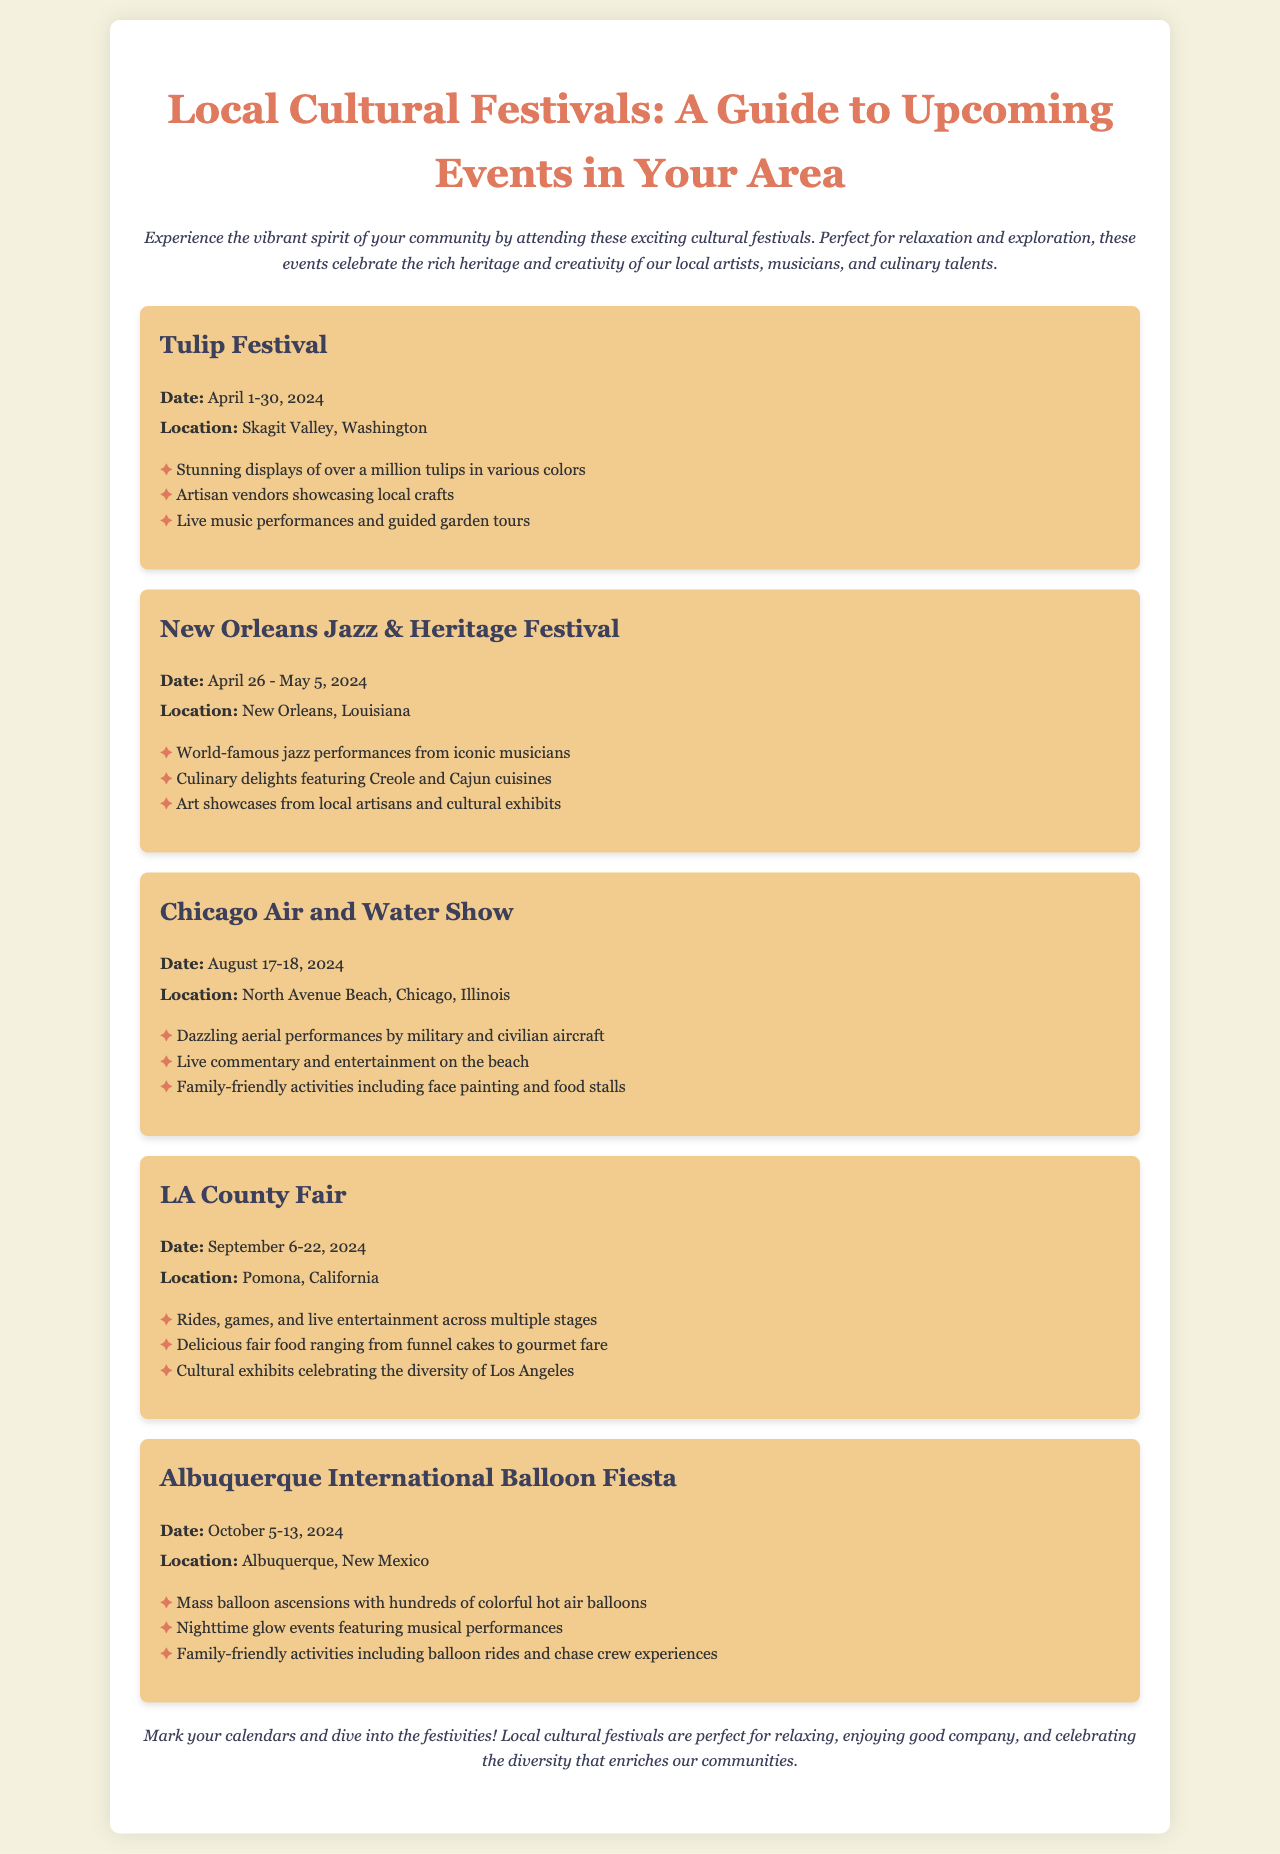What is the date of the Tulip Festival? The date of the Tulip Festival is listed as April 1-30, 2024.
Answer: April 1-30, 2024 Where is the New Orleans Jazz & Heritage Festival located? The location of the New Orleans Jazz & Heritage Festival is mentioned as New Orleans, Louisiana.
Answer: New Orleans, Louisiana Which festival features hot air balloons? The festival that features hot air balloons is the Albuquerque International Balloon Fiesta.
Answer: Albuquerque International Balloon Fiesta What is one of the highlights of the LA County Fair? One of the highlights of the LA County Fair includes rides, games, and live entertainment across multiple stages.
Answer: Rides, games, and live entertainment How many days does the Chicago Air and Water Show last? The Chicago Air and Water Show lasts for two days, as indicated by the dates August 17-18, 2024.
Answer: Two days What type of cuisine is showcased at the New Orleans Jazz & Heritage Festival? The festival showcases Creole and Cajun cuisines.
Answer: Creole and Cajun cuisines What is one activity available for families at the Albuquerque International Balloon Fiesta? One of the family-friendly activities available is balloon rides.
Answer: Balloon rides What is the purpose of this brochure? The purpose of the brochure is to guide readers to upcoming cultural festivals in their area.
Answer: To guide readers to upcoming cultural festivals 